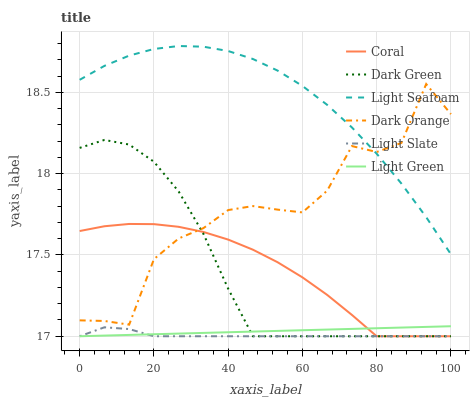Does Light Slate have the minimum area under the curve?
Answer yes or no. Yes. Does Light Seafoam have the maximum area under the curve?
Answer yes or no. Yes. Does Coral have the minimum area under the curve?
Answer yes or no. No. Does Coral have the maximum area under the curve?
Answer yes or no. No. Is Light Green the smoothest?
Answer yes or no. Yes. Is Dark Orange the roughest?
Answer yes or no. Yes. Is Light Slate the smoothest?
Answer yes or no. No. Is Light Slate the roughest?
Answer yes or no. No. Does Light Slate have the lowest value?
Answer yes or no. Yes. Does Light Seafoam have the lowest value?
Answer yes or no. No. Does Light Seafoam have the highest value?
Answer yes or no. Yes. Does Coral have the highest value?
Answer yes or no. No. Is Dark Green less than Light Seafoam?
Answer yes or no. Yes. Is Light Seafoam greater than Light Slate?
Answer yes or no. Yes. Does Light Slate intersect Dark Green?
Answer yes or no. Yes. Is Light Slate less than Dark Green?
Answer yes or no. No. Is Light Slate greater than Dark Green?
Answer yes or no. No. Does Dark Green intersect Light Seafoam?
Answer yes or no. No. 